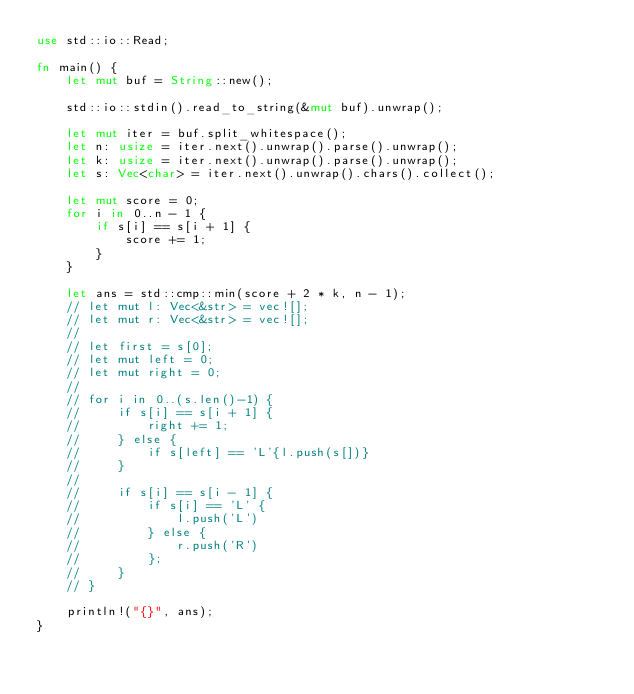<code> <loc_0><loc_0><loc_500><loc_500><_Rust_>use std::io::Read;

fn main() {
    let mut buf = String::new();

    std::io::stdin().read_to_string(&mut buf).unwrap();

    let mut iter = buf.split_whitespace();
    let n: usize = iter.next().unwrap().parse().unwrap();
    let k: usize = iter.next().unwrap().parse().unwrap();
    let s: Vec<char> = iter.next().unwrap().chars().collect();

    let mut score = 0;
    for i in 0..n - 1 {
        if s[i] == s[i + 1] {
            score += 1;
        }
    }

    let ans = std::cmp::min(score + 2 * k, n - 1);
    // let mut l: Vec<&str> = vec![];
    // let mut r: Vec<&str> = vec![];
    //
    // let first = s[0];
    // let mut left = 0;
    // let mut right = 0;
    //
    // for i in 0..(s.len()-1) {
    //     if s[i] == s[i + 1] {
    //         right += 1;
    //     } else {
    //         if s[left] == 'L'{l.push(s[])}
    //     }
    //
    //     if s[i] == s[i - 1] {
    //         if s[i] == 'L' {
    //             l.push('L')
    //         } else {
    //             r.push('R')
    //         };
    //     }
    // }

    println!("{}", ans);
}
</code> 